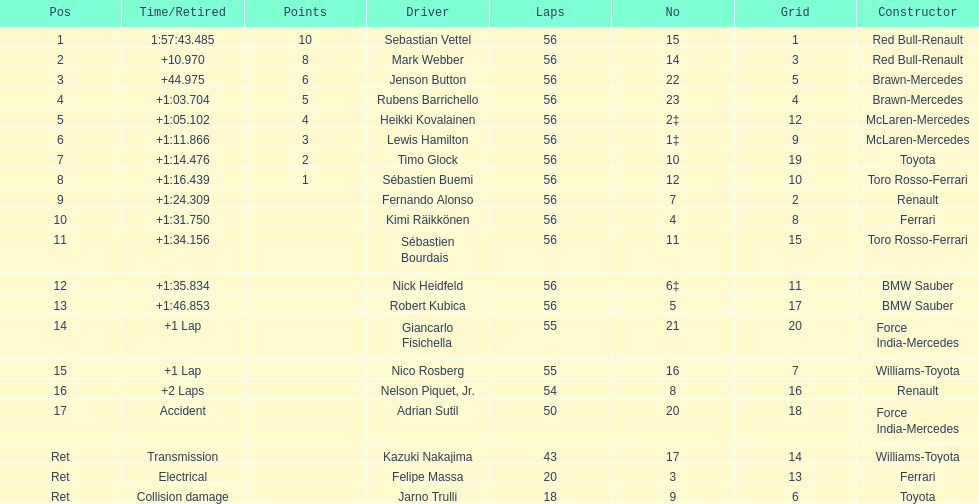Who was the slowest driver to finish the race? Robert Kubica. 